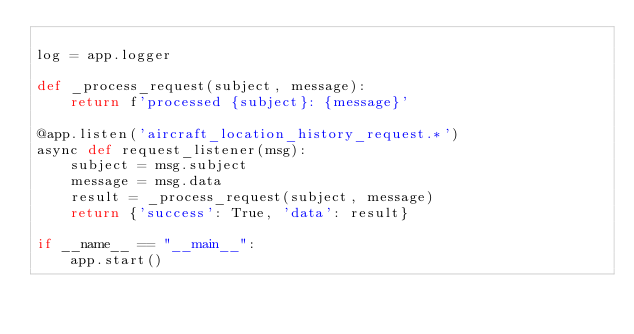Convert code to text. <code><loc_0><loc_0><loc_500><loc_500><_Python_>
log = app.logger

def _process_request(subject, message):
    return f'processed {subject}: {message}'

@app.listen('aircraft_location_history_request.*')
async def request_listener(msg):
    subject = msg.subject
    message = msg.data
    result = _process_request(subject, message)
    return {'success': True, 'data': result}

if __name__ == "__main__":
    app.start()
</code> 